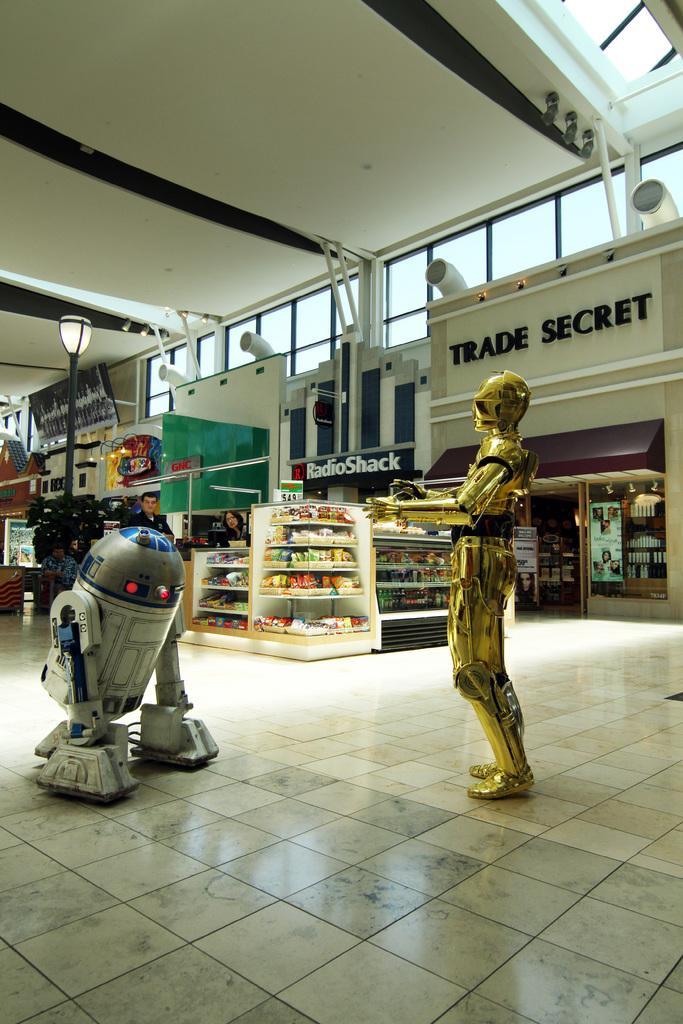How would you summarize this image in a sentence or two? In this image, there are a few people, robots. We can see some shelves with objects. We can also see some boards with text. We can see the wall with some objects attached to it. We can see a pole and the roof. We can see the ground with some objects. 